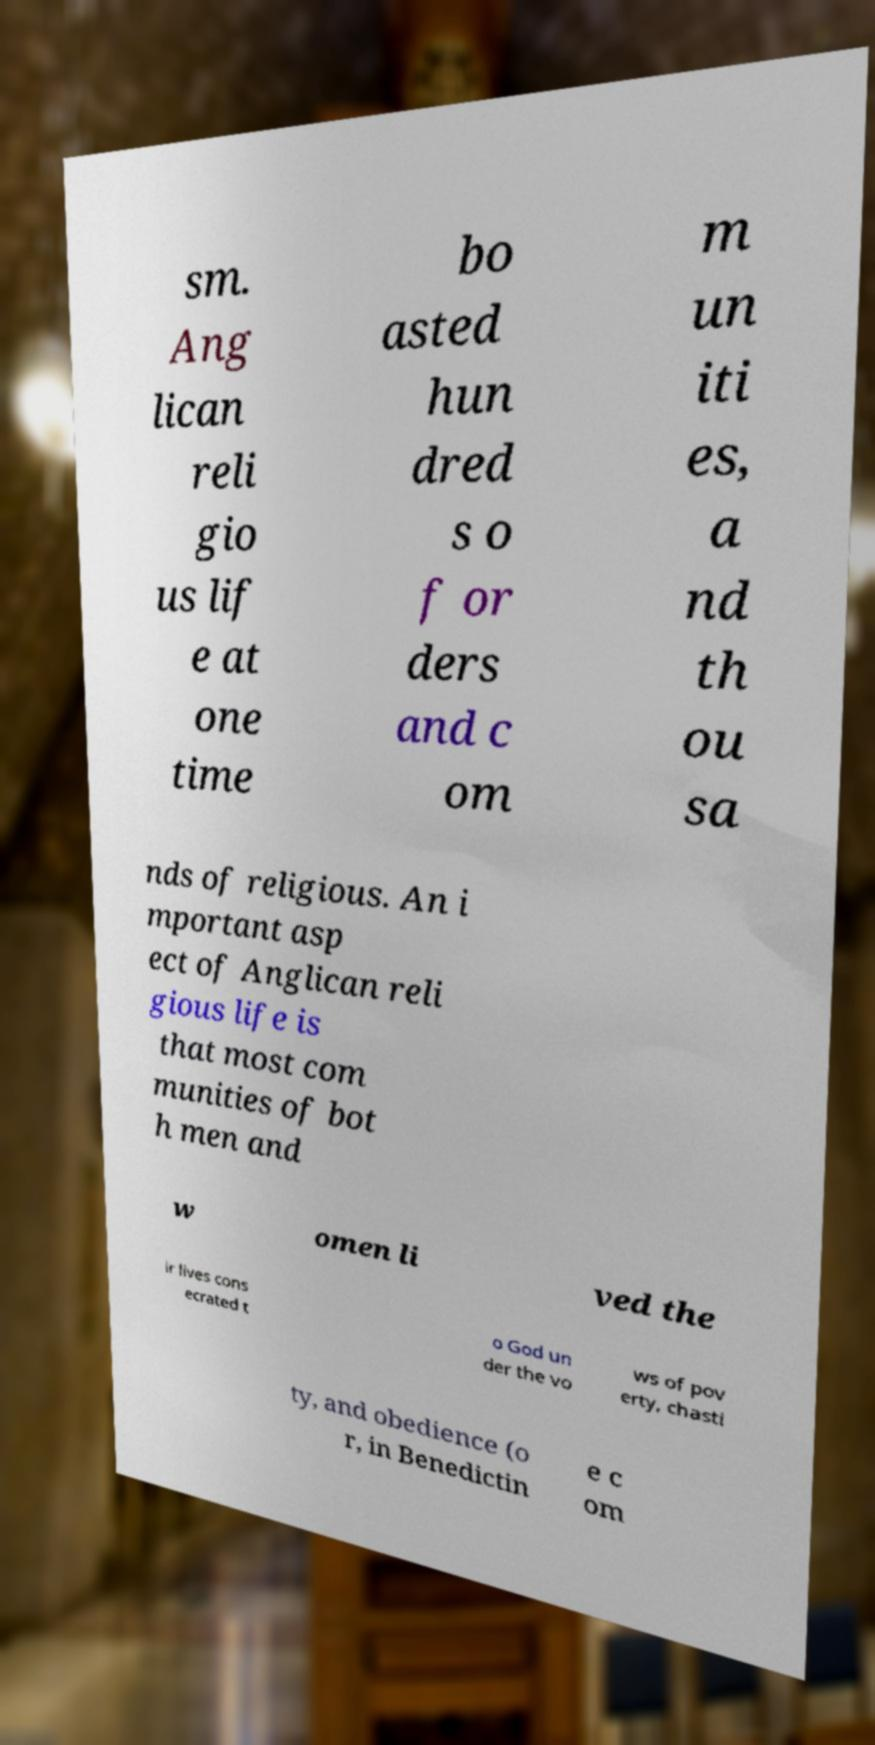I need the written content from this picture converted into text. Can you do that? sm. Ang lican reli gio us lif e at one time bo asted hun dred s o f or ders and c om m un iti es, a nd th ou sa nds of religious. An i mportant asp ect of Anglican reli gious life is that most com munities of bot h men and w omen li ved the ir lives cons ecrated t o God un der the vo ws of pov erty, chasti ty, and obedience (o r, in Benedictin e c om 